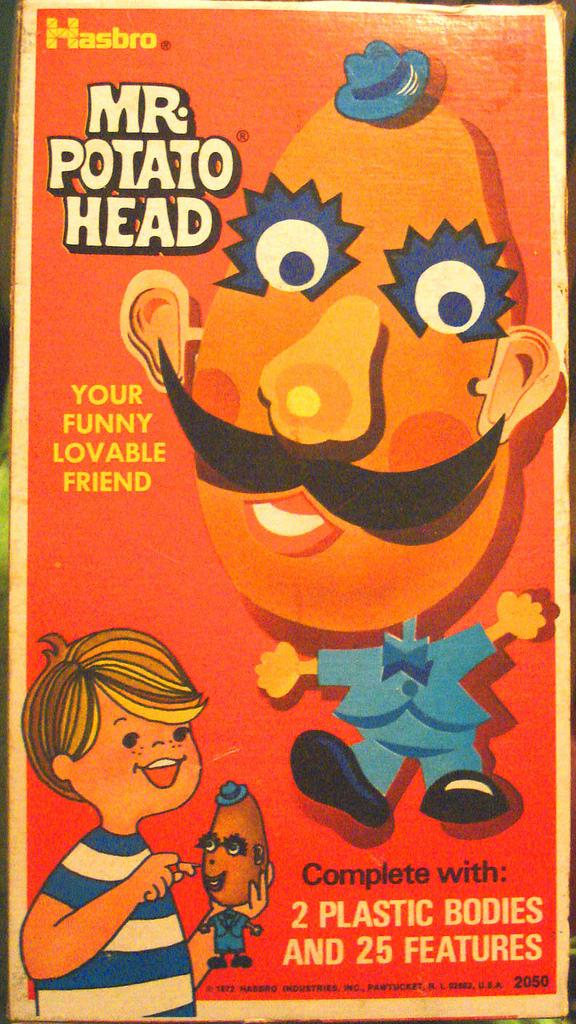<image>
Write a terse but informative summary of the picture. A poster for Mr. Potato Head says Complete with 2 Plastic Bodies and 25 Features. 